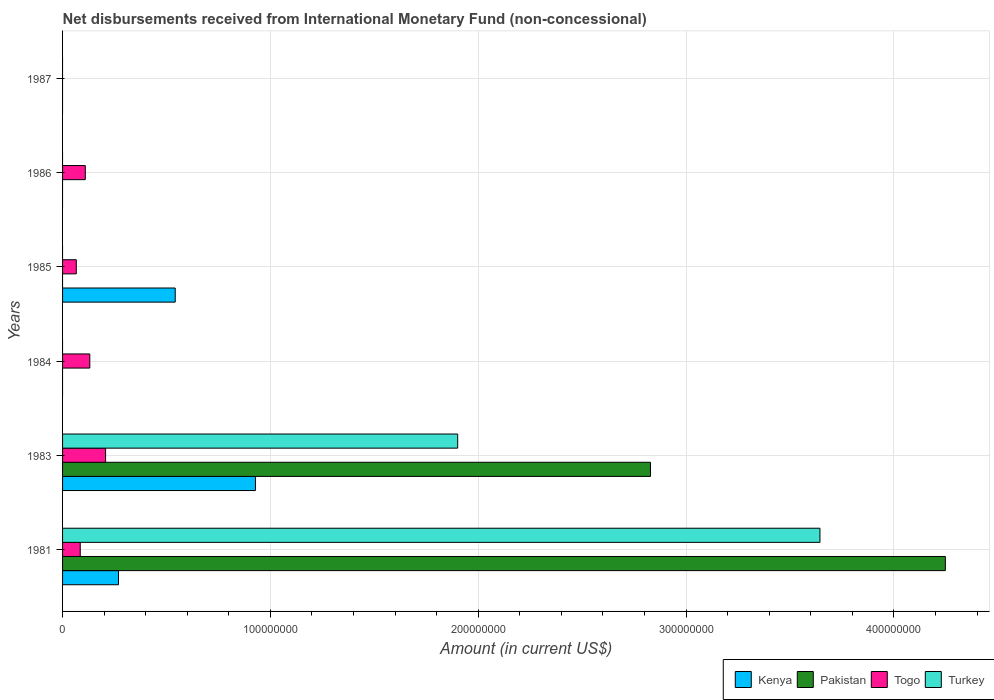Are the number of bars per tick equal to the number of legend labels?
Provide a succinct answer. No. Are the number of bars on each tick of the Y-axis equal?
Your response must be concise. No. How many bars are there on the 2nd tick from the bottom?
Offer a terse response. 4. What is the amount of disbursements received from International Monetary Fund in Pakistan in 1987?
Provide a short and direct response. 0. Across all years, what is the maximum amount of disbursements received from International Monetary Fund in Togo?
Keep it short and to the point. 2.07e+07. What is the total amount of disbursements received from International Monetary Fund in Kenya in the graph?
Offer a very short reply. 1.74e+08. What is the difference between the amount of disbursements received from International Monetary Fund in Togo in 1983 and that in 1985?
Ensure brevity in your answer.  1.41e+07. What is the difference between the amount of disbursements received from International Monetary Fund in Kenya in 1986 and the amount of disbursements received from International Monetary Fund in Pakistan in 1984?
Your answer should be very brief. 0. What is the average amount of disbursements received from International Monetary Fund in Togo per year?
Provide a succinct answer. 9.97e+06. In the year 1983, what is the difference between the amount of disbursements received from International Monetary Fund in Pakistan and amount of disbursements received from International Monetary Fund in Turkey?
Give a very brief answer. 9.28e+07. In how many years, is the amount of disbursements received from International Monetary Fund in Turkey greater than 260000000 US$?
Make the answer very short. 1. Is the amount of disbursements received from International Monetary Fund in Kenya in 1981 less than that in 1985?
Ensure brevity in your answer.  Yes. What is the difference between the highest and the second highest amount of disbursements received from International Monetary Fund in Togo?
Offer a very short reply. 7.60e+06. What is the difference between the highest and the lowest amount of disbursements received from International Monetary Fund in Kenya?
Provide a short and direct response. 9.28e+07. In how many years, is the amount of disbursements received from International Monetary Fund in Turkey greater than the average amount of disbursements received from International Monetary Fund in Turkey taken over all years?
Ensure brevity in your answer.  2. Is the sum of the amount of disbursements received from International Monetary Fund in Togo in 1981 and 1986 greater than the maximum amount of disbursements received from International Monetary Fund in Pakistan across all years?
Your response must be concise. No. How many bars are there?
Offer a very short reply. 12. What is the difference between two consecutive major ticks on the X-axis?
Your answer should be compact. 1.00e+08. Does the graph contain any zero values?
Offer a very short reply. Yes. Where does the legend appear in the graph?
Provide a short and direct response. Bottom right. How many legend labels are there?
Make the answer very short. 4. How are the legend labels stacked?
Your response must be concise. Horizontal. What is the title of the graph?
Your response must be concise. Net disbursements received from International Monetary Fund (non-concessional). Does "High income: nonOECD" appear as one of the legend labels in the graph?
Provide a succinct answer. No. What is the label or title of the Y-axis?
Your response must be concise. Years. What is the Amount (in current US$) of Kenya in 1981?
Your answer should be compact. 2.69e+07. What is the Amount (in current US$) of Pakistan in 1981?
Keep it short and to the point. 4.25e+08. What is the Amount (in current US$) of Togo in 1981?
Offer a terse response. 8.50e+06. What is the Amount (in current US$) in Turkey in 1981?
Offer a terse response. 3.64e+08. What is the Amount (in current US$) in Kenya in 1983?
Provide a short and direct response. 9.28e+07. What is the Amount (in current US$) of Pakistan in 1983?
Give a very brief answer. 2.83e+08. What is the Amount (in current US$) in Togo in 1983?
Ensure brevity in your answer.  2.07e+07. What is the Amount (in current US$) in Turkey in 1983?
Your answer should be very brief. 1.90e+08. What is the Amount (in current US$) of Pakistan in 1984?
Your answer should be compact. 0. What is the Amount (in current US$) in Togo in 1984?
Make the answer very short. 1.31e+07. What is the Amount (in current US$) in Turkey in 1984?
Your response must be concise. 0. What is the Amount (in current US$) of Kenya in 1985?
Offer a very short reply. 5.42e+07. What is the Amount (in current US$) of Togo in 1985?
Give a very brief answer. 6.60e+06. What is the Amount (in current US$) in Turkey in 1985?
Offer a very short reply. 0. What is the Amount (in current US$) of Kenya in 1986?
Your answer should be compact. 0. What is the Amount (in current US$) in Togo in 1986?
Give a very brief answer. 1.09e+07. What is the Amount (in current US$) of Kenya in 1987?
Your response must be concise. 0. What is the Amount (in current US$) in Pakistan in 1987?
Your answer should be very brief. 0. What is the Amount (in current US$) in Togo in 1987?
Your answer should be compact. 0. What is the Amount (in current US$) in Turkey in 1987?
Your response must be concise. 0. Across all years, what is the maximum Amount (in current US$) in Kenya?
Make the answer very short. 9.28e+07. Across all years, what is the maximum Amount (in current US$) in Pakistan?
Provide a succinct answer. 4.25e+08. Across all years, what is the maximum Amount (in current US$) in Togo?
Offer a very short reply. 2.07e+07. Across all years, what is the maximum Amount (in current US$) in Turkey?
Your answer should be very brief. 3.64e+08. Across all years, what is the minimum Amount (in current US$) in Togo?
Keep it short and to the point. 0. Across all years, what is the minimum Amount (in current US$) of Turkey?
Give a very brief answer. 0. What is the total Amount (in current US$) in Kenya in the graph?
Offer a terse response. 1.74e+08. What is the total Amount (in current US$) in Pakistan in the graph?
Your response must be concise. 7.08e+08. What is the total Amount (in current US$) in Togo in the graph?
Offer a terse response. 5.98e+07. What is the total Amount (in current US$) in Turkey in the graph?
Offer a terse response. 5.54e+08. What is the difference between the Amount (in current US$) of Kenya in 1981 and that in 1983?
Provide a short and direct response. -6.59e+07. What is the difference between the Amount (in current US$) of Pakistan in 1981 and that in 1983?
Ensure brevity in your answer.  1.42e+08. What is the difference between the Amount (in current US$) in Togo in 1981 and that in 1983?
Offer a terse response. -1.22e+07. What is the difference between the Amount (in current US$) in Turkey in 1981 and that in 1983?
Offer a very short reply. 1.74e+08. What is the difference between the Amount (in current US$) in Togo in 1981 and that in 1984?
Offer a very short reply. -4.60e+06. What is the difference between the Amount (in current US$) of Kenya in 1981 and that in 1985?
Offer a very short reply. -2.73e+07. What is the difference between the Amount (in current US$) in Togo in 1981 and that in 1985?
Your response must be concise. 1.90e+06. What is the difference between the Amount (in current US$) in Togo in 1981 and that in 1986?
Provide a succinct answer. -2.44e+06. What is the difference between the Amount (in current US$) in Togo in 1983 and that in 1984?
Offer a terse response. 7.60e+06. What is the difference between the Amount (in current US$) in Kenya in 1983 and that in 1985?
Keep it short and to the point. 3.86e+07. What is the difference between the Amount (in current US$) of Togo in 1983 and that in 1985?
Offer a terse response. 1.41e+07. What is the difference between the Amount (in current US$) of Togo in 1983 and that in 1986?
Offer a very short reply. 9.76e+06. What is the difference between the Amount (in current US$) in Togo in 1984 and that in 1985?
Offer a very short reply. 6.50e+06. What is the difference between the Amount (in current US$) in Togo in 1984 and that in 1986?
Your answer should be very brief. 2.16e+06. What is the difference between the Amount (in current US$) in Togo in 1985 and that in 1986?
Provide a short and direct response. -4.34e+06. What is the difference between the Amount (in current US$) of Kenya in 1981 and the Amount (in current US$) of Pakistan in 1983?
Keep it short and to the point. -2.56e+08. What is the difference between the Amount (in current US$) of Kenya in 1981 and the Amount (in current US$) of Togo in 1983?
Your answer should be compact. 6.20e+06. What is the difference between the Amount (in current US$) of Kenya in 1981 and the Amount (in current US$) of Turkey in 1983?
Offer a very short reply. -1.63e+08. What is the difference between the Amount (in current US$) in Pakistan in 1981 and the Amount (in current US$) in Togo in 1983?
Give a very brief answer. 4.04e+08. What is the difference between the Amount (in current US$) in Pakistan in 1981 and the Amount (in current US$) in Turkey in 1983?
Make the answer very short. 2.35e+08. What is the difference between the Amount (in current US$) in Togo in 1981 and the Amount (in current US$) in Turkey in 1983?
Ensure brevity in your answer.  -1.82e+08. What is the difference between the Amount (in current US$) in Kenya in 1981 and the Amount (in current US$) in Togo in 1984?
Your answer should be very brief. 1.38e+07. What is the difference between the Amount (in current US$) of Pakistan in 1981 and the Amount (in current US$) of Togo in 1984?
Make the answer very short. 4.12e+08. What is the difference between the Amount (in current US$) of Kenya in 1981 and the Amount (in current US$) of Togo in 1985?
Your answer should be very brief. 2.03e+07. What is the difference between the Amount (in current US$) of Pakistan in 1981 and the Amount (in current US$) of Togo in 1985?
Offer a very short reply. 4.18e+08. What is the difference between the Amount (in current US$) in Kenya in 1981 and the Amount (in current US$) in Togo in 1986?
Give a very brief answer. 1.60e+07. What is the difference between the Amount (in current US$) in Pakistan in 1981 and the Amount (in current US$) in Togo in 1986?
Make the answer very short. 4.14e+08. What is the difference between the Amount (in current US$) of Kenya in 1983 and the Amount (in current US$) of Togo in 1984?
Offer a very short reply. 7.97e+07. What is the difference between the Amount (in current US$) of Pakistan in 1983 and the Amount (in current US$) of Togo in 1984?
Give a very brief answer. 2.70e+08. What is the difference between the Amount (in current US$) of Kenya in 1983 and the Amount (in current US$) of Togo in 1985?
Ensure brevity in your answer.  8.62e+07. What is the difference between the Amount (in current US$) in Pakistan in 1983 and the Amount (in current US$) in Togo in 1985?
Your response must be concise. 2.76e+08. What is the difference between the Amount (in current US$) in Kenya in 1983 and the Amount (in current US$) in Togo in 1986?
Keep it short and to the point. 8.19e+07. What is the difference between the Amount (in current US$) of Pakistan in 1983 and the Amount (in current US$) of Togo in 1986?
Provide a succinct answer. 2.72e+08. What is the difference between the Amount (in current US$) of Kenya in 1985 and the Amount (in current US$) of Togo in 1986?
Your answer should be compact. 4.33e+07. What is the average Amount (in current US$) in Kenya per year?
Your answer should be very brief. 2.90e+07. What is the average Amount (in current US$) of Pakistan per year?
Your response must be concise. 1.18e+08. What is the average Amount (in current US$) of Togo per year?
Ensure brevity in your answer.  9.97e+06. What is the average Amount (in current US$) of Turkey per year?
Offer a terse response. 9.24e+07. In the year 1981, what is the difference between the Amount (in current US$) in Kenya and Amount (in current US$) in Pakistan?
Keep it short and to the point. -3.98e+08. In the year 1981, what is the difference between the Amount (in current US$) of Kenya and Amount (in current US$) of Togo?
Offer a terse response. 1.84e+07. In the year 1981, what is the difference between the Amount (in current US$) in Kenya and Amount (in current US$) in Turkey?
Provide a succinct answer. -3.38e+08. In the year 1981, what is the difference between the Amount (in current US$) of Pakistan and Amount (in current US$) of Togo?
Offer a very short reply. 4.16e+08. In the year 1981, what is the difference between the Amount (in current US$) of Pakistan and Amount (in current US$) of Turkey?
Your answer should be compact. 6.03e+07. In the year 1981, what is the difference between the Amount (in current US$) in Togo and Amount (in current US$) in Turkey?
Your answer should be very brief. -3.56e+08. In the year 1983, what is the difference between the Amount (in current US$) of Kenya and Amount (in current US$) of Pakistan?
Your response must be concise. -1.90e+08. In the year 1983, what is the difference between the Amount (in current US$) of Kenya and Amount (in current US$) of Togo?
Ensure brevity in your answer.  7.21e+07. In the year 1983, what is the difference between the Amount (in current US$) of Kenya and Amount (in current US$) of Turkey?
Provide a short and direct response. -9.73e+07. In the year 1983, what is the difference between the Amount (in current US$) of Pakistan and Amount (in current US$) of Togo?
Keep it short and to the point. 2.62e+08. In the year 1983, what is the difference between the Amount (in current US$) in Pakistan and Amount (in current US$) in Turkey?
Offer a very short reply. 9.28e+07. In the year 1983, what is the difference between the Amount (in current US$) of Togo and Amount (in current US$) of Turkey?
Make the answer very short. -1.69e+08. In the year 1985, what is the difference between the Amount (in current US$) of Kenya and Amount (in current US$) of Togo?
Provide a succinct answer. 4.76e+07. What is the ratio of the Amount (in current US$) in Kenya in 1981 to that in 1983?
Ensure brevity in your answer.  0.29. What is the ratio of the Amount (in current US$) of Pakistan in 1981 to that in 1983?
Make the answer very short. 1.5. What is the ratio of the Amount (in current US$) of Togo in 1981 to that in 1983?
Ensure brevity in your answer.  0.41. What is the ratio of the Amount (in current US$) of Turkey in 1981 to that in 1983?
Provide a succinct answer. 1.92. What is the ratio of the Amount (in current US$) in Togo in 1981 to that in 1984?
Give a very brief answer. 0.65. What is the ratio of the Amount (in current US$) of Kenya in 1981 to that in 1985?
Provide a succinct answer. 0.5. What is the ratio of the Amount (in current US$) in Togo in 1981 to that in 1985?
Make the answer very short. 1.29. What is the ratio of the Amount (in current US$) in Togo in 1981 to that in 1986?
Provide a succinct answer. 0.78. What is the ratio of the Amount (in current US$) in Togo in 1983 to that in 1984?
Ensure brevity in your answer.  1.58. What is the ratio of the Amount (in current US$) in Kenya in 1983 to that in 1985?
Your response must be concise. 1.71. What is the ratio of the Amount (in current US$) in Togo in 1983 to that in 1985?
Ensure brevity in your answer.  3.14. What is the ratio of the Amount (in current US$) of Togo in 1983 to that in 1986?
Give a very brief answer. 1.89. What is the ratio of the Amount (in current US$) in Togo in 1984 to that in 1985?
Offer a very short reply. 1.98. What is the ratio of the Amount (in current US$) of Togo in 1984 to that in 1986?
Your answer should be very brief. 1.2. What is the ratio of the Amount (in current US$) in Togo in 1985 to that in 1986?
Provide a short and direct response. 0.6. What is the difference between the highest and the second highest Amount (in current US$) of Kenya?
Provide a short and direct response. 3.86e+07. What is the difference between the highest and the second highest Amount (in current US$) in Togo?
Provide a succinct answer. 7.60e+06. What is the difference between the highest and the lowest Amount (in current US$) of Kenya?
Provide a succinct answer. 9.28e+07. What is the difference between the highest and the lowest Amount (in current US$) of Pakistan?
Ensure brevity in your answer.  4.25e+08. What is the difference between the highest and the lowest Amount (in current US$) of Togo?
Make the answer very short. 2.07e+07. What is the difference between the highest and the lowest Amount (in current US$) of Turkey?
Keep it short and to the point. 3.64e+08. 